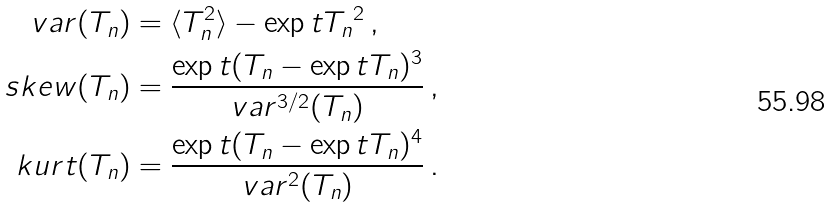<formula> <loc_0><loc_0><loc_500><loc_500>v a r ( T _ { n } ) & = \langle T _ { n } ^ { 2 } \rangle - \exp t { T _ { n } } ^ { 2 } \, , \\ s k e w ( T _ { n } ) & = \frac { \exp t { ( T _ { n } - \exp t { T _ { n } } ) ^ { 3 } } } { v a r ^ { 3 / 2 } ( T _ { n } ) } \, , \\ k u r t ( T _ { n } ) & = \frac { \exp t { ( T _ { n } - \exp t { T _ { n } } ) ^ { 4 } } } { v a r ^ { 2 } ( T _ { n } ) } \, .</formula> 